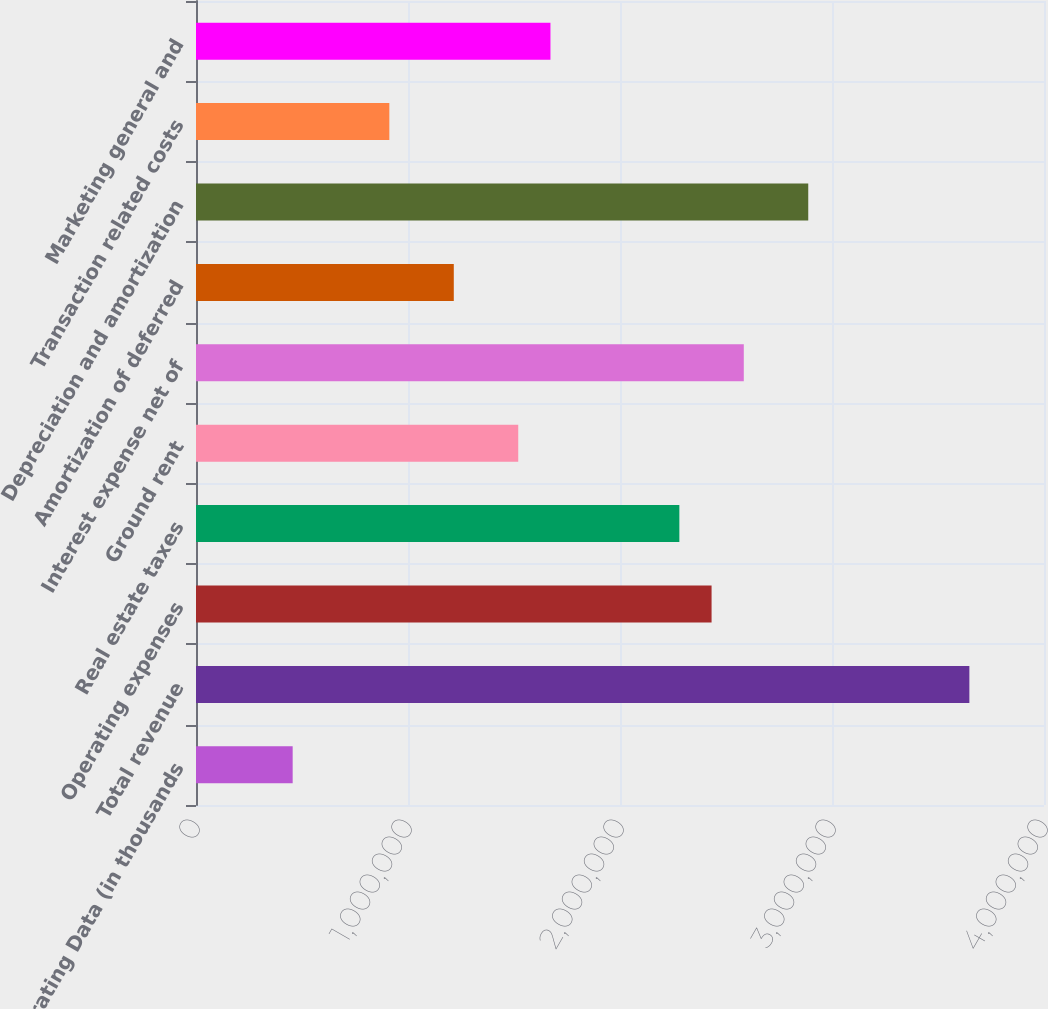Convert chart. <chart><loc_0><loc_0><loc_500><loc_500><bar_chart><fcel>Operating Data (in thousands<fcel>Total revenue<fcel>Operating expenses<fcel>Real estate taxes<fcel>Ground rent<fcel>Interest expense net of<fcel>Amortization of deferred<fcel>Depreciation and amortization<fcel>Transaction related costs<fcel>Marketing general and<nl><fcel>455995<fcel>3.64794e+06<fcel>2.43196e+06<fcel>2.27997e+06<fcel>1.51998e+06<fcel>2.58396e+06<fcel>1.21598e+06<fcel>2.88796e+06<fcel>911988<fcel>1.67198e+06<nl></chart> 